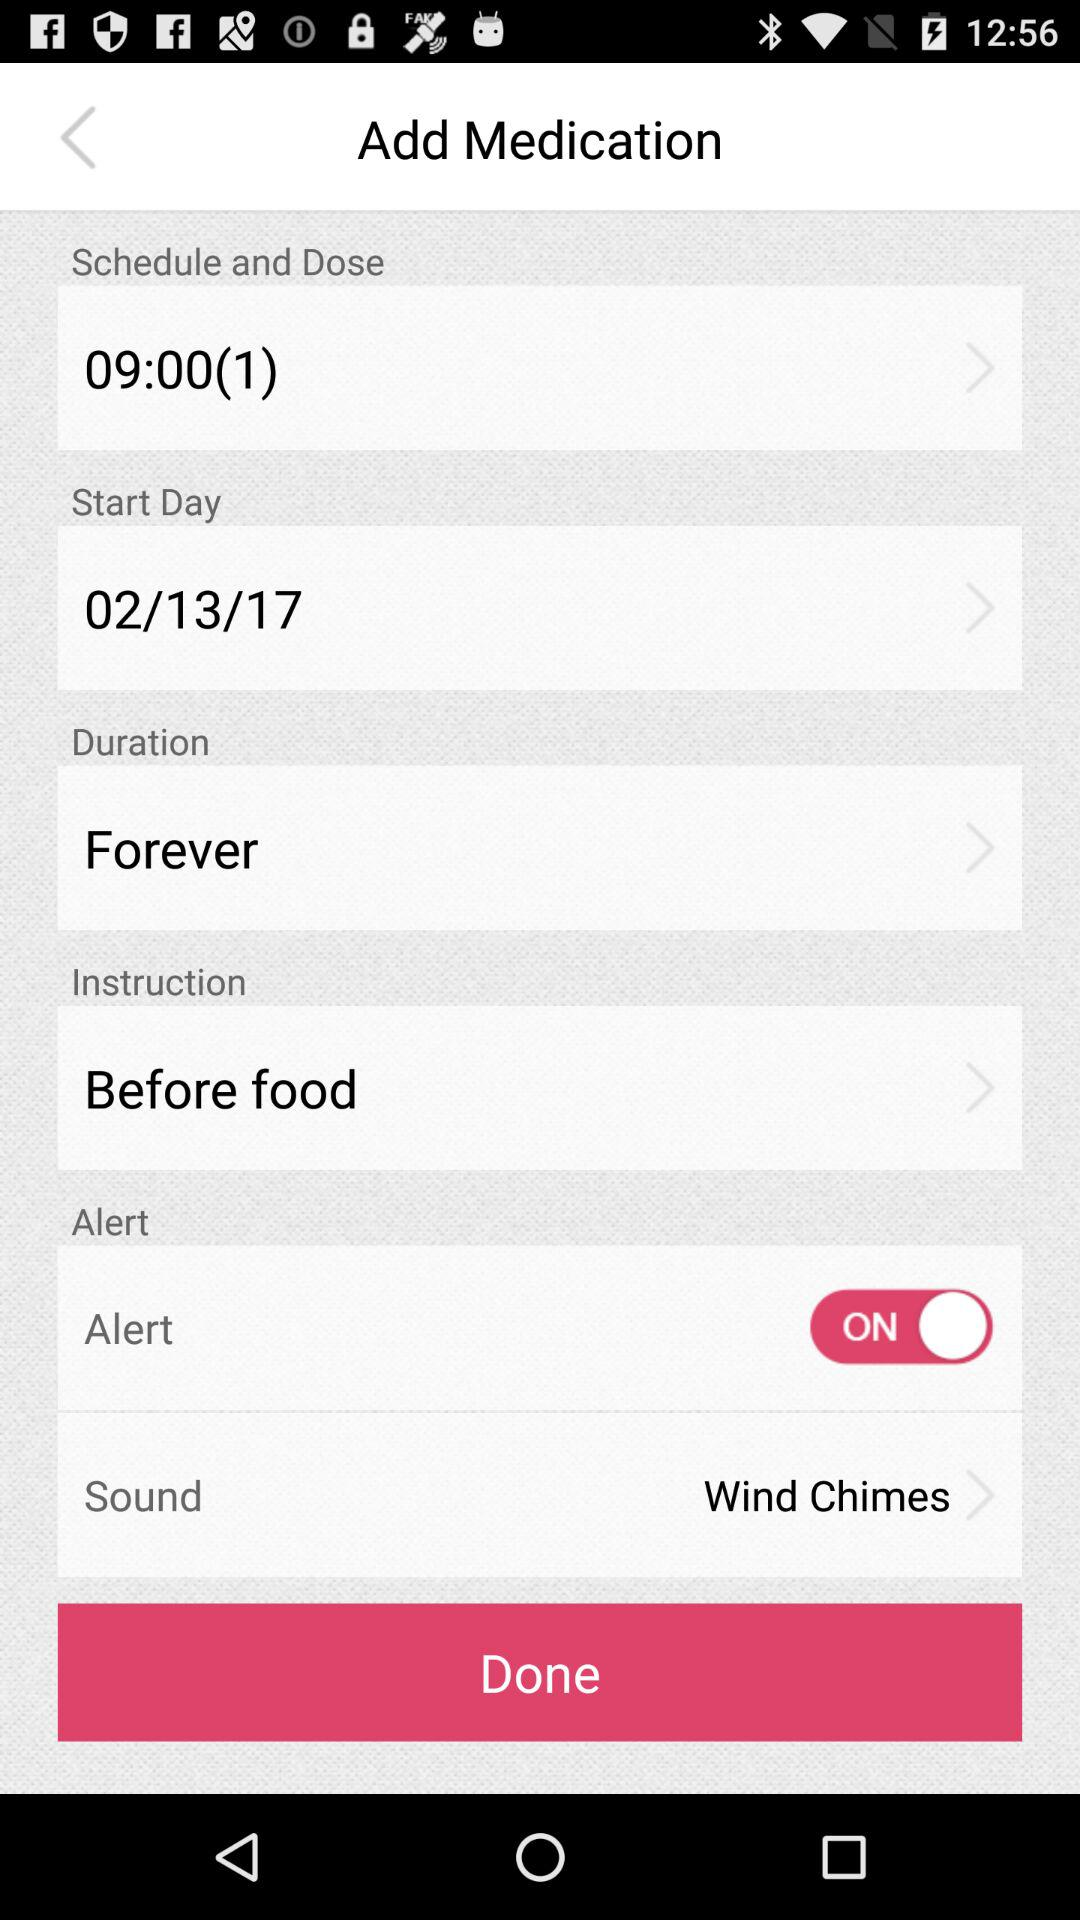What is the setting of "Sound"? The setting is "Wind Chimes". 